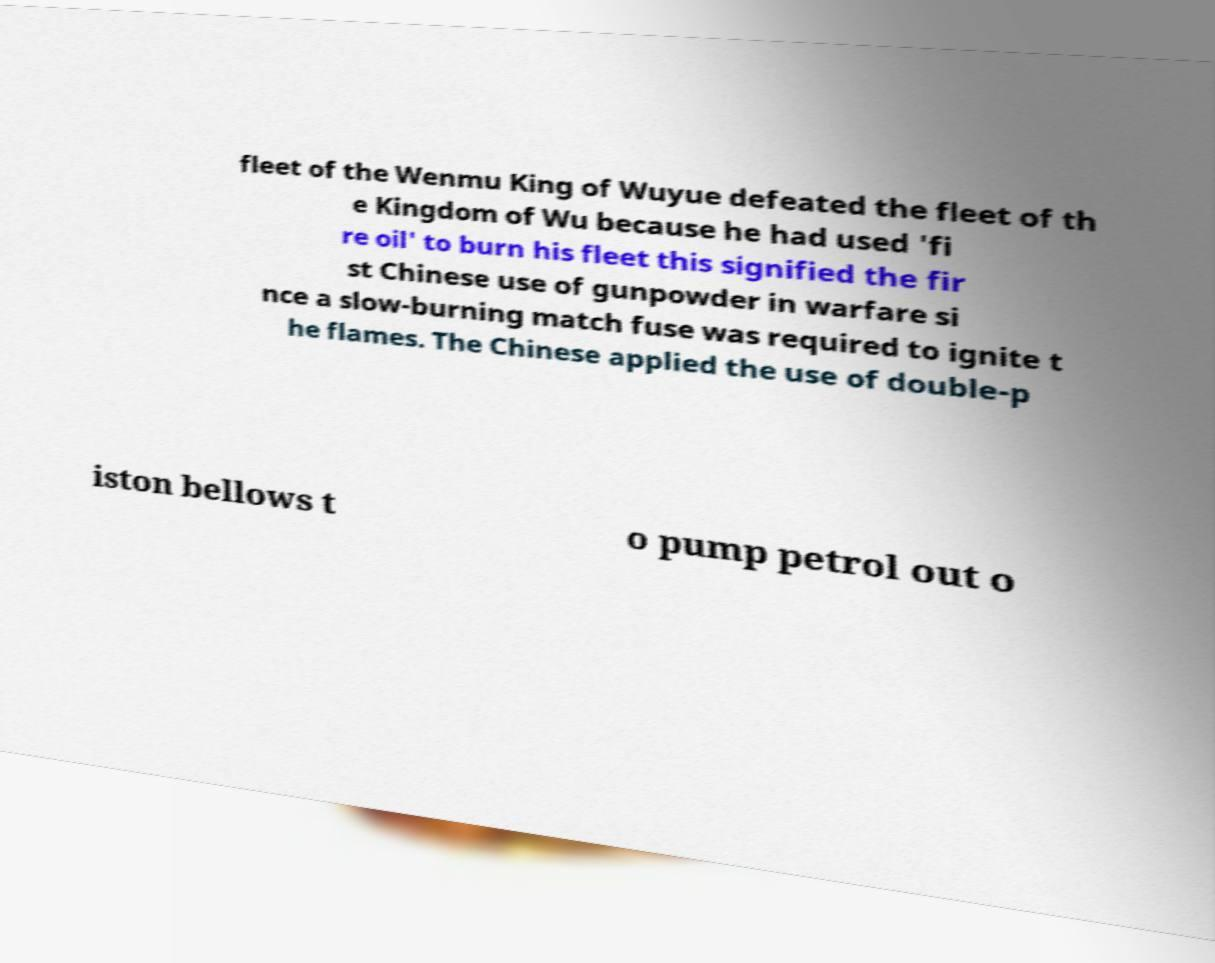Can you read and provide the text displayed in the image?This photo seems to have some interesting text. Can you extract and type it out for me? fleet of the Wenmu King of Wuyue defeated the fleet of th e Kingdom of Wu because he had used 'fi re oil' to burn his fleet this signified the fir st Chinese use of gunpowder in warfare si nce a slow-burning match fuse was required to ignite t he flames. The Chinese applied the use of double-p iston bellows t o pump petrol out o 